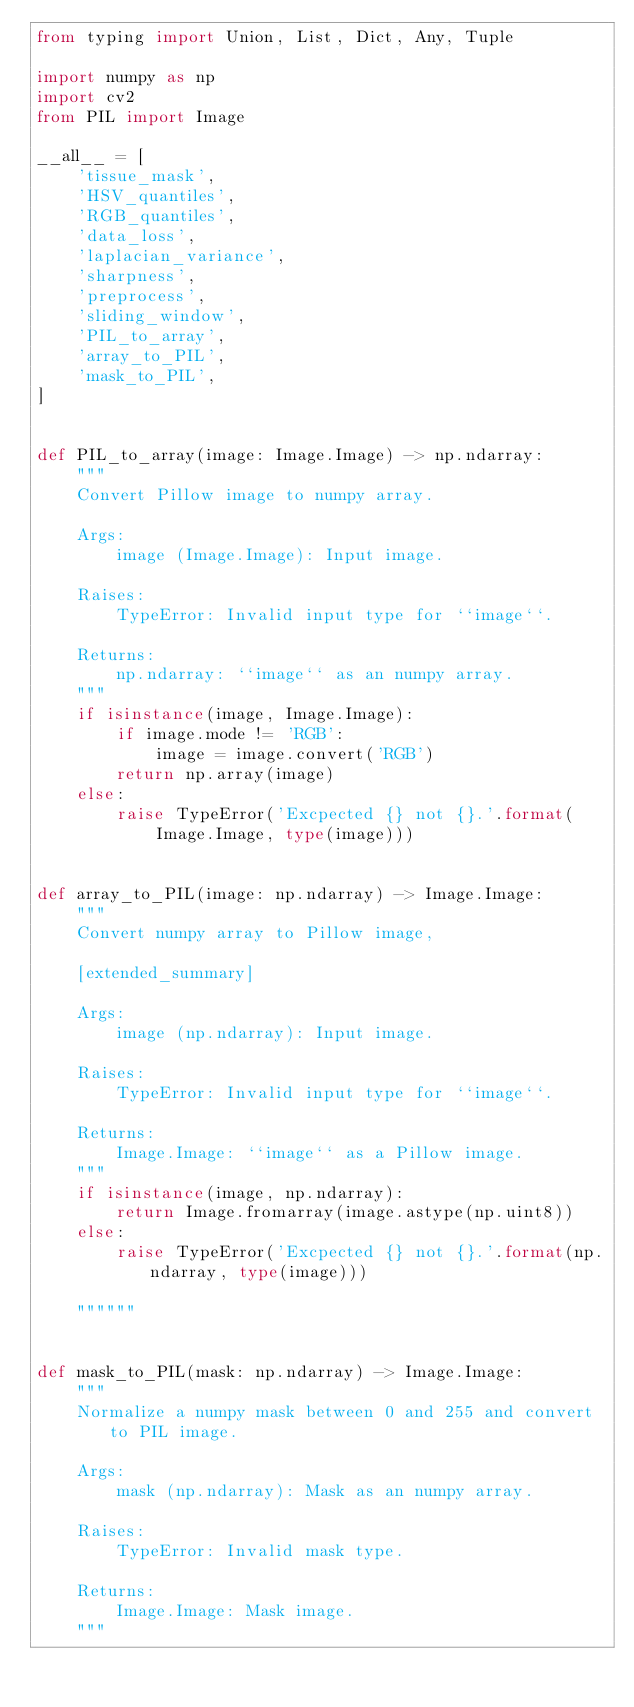<code> <loc_0><loc_0><loc_500><loc_500><_Python_>from typing import Union, List, Dict, Any, Tuple

import numpy as np
import cv2
from PIL import Image

__all__ = [
    'tissue_mask',
    'HSV_quantiles',
    'RGB_quantiles',
    'data_loss',
    'laplacian_variance',
    'sharpness',
    'preprocess',
    'sliding_window',
    'PIL_to_array',
    'array_to_PIL',
    'mask_to_PIL',
]


def PIL_to_array(image: Image.Image) -> np.ndarray:
    """
    Convert Pillow image to numpy array.

    Args:
        image (Image.Image): Input image.

    Raises:
        TypeError: Invalid input type for ``image``.

    Returns:
        np.ndarray: ``image`` as an numpy array.
    """
    if isinstance(image, Image.Image):
        if image.mode != 'RGB':
            image = image.convert('RGB')
        return np.array(image)
    else:
        raise TypeError('Excpected {} not {}.'.format(
            Image.Image, type(image)))


def array_to_PIL(image: np.ndarray) -> Image.Image:
    """
    Convert numpy array to Pillow image,

    [extended_summary]

    Args:
        image (np.ndarray): Input image.

    Raises:
        TypeError: Invalid input type for ``image``.

    Returns:
        Image.Image: ``image`` as a Pillow image.
    """
    if isinstance(image, np.ndarray):
        return Image.fromarray(image.astype(np.uint8))
    else:
        raise TypeError('Excpected {} not {}.'.format(np.ndarray, type(image)))

    """"""


def mask_to_PIL(mask: np.ndarray) -> Image.Image:
    """
    Normalize a numpy mask between 0 and 255 and convert to PIL image.

    Args:
        mask (np.ndarray): Mask as an numpy array.

    Raises:
        TypeError: Invalid mask type.

    Returns:
        Image.Image: Mask image.
    """</code> 